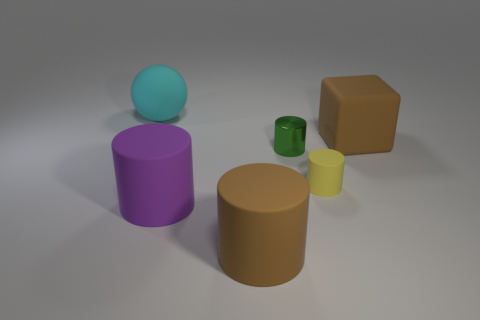What number of objects are either tiny red objects or brown rubber objects?
Ensure brevity in your answer.  2. What size is the brown rubber thing that is the same shape as the green object?
Your response must be concise. Large. The cyan matte object has what size?
Provide a short and direct response. Large. Are there more yellow rubber objects that are in front of the large matte ball than small red blocks?
Provide a short and direct response. Yes. Is there any other thing that is made of the same material as the tiny green object?
Make the answer very short. No. There is a large matte object to the right of the green metal cylinder; is it the same color as the matte cylinder in front of the large purple cylinder?
Your response must be concise. Yes. What is the material of the object that is on the right side of the tiny cylinder in front of the cylinder behind the tiny yellow cylinder?
Provide a short and direct response. Rubber. Is the number of big things greater than the number of things?
Provide a short and direct response. No. Is there anything else that has the same color as the big rubber block?
Your answer should be very brief. Yes. The brown block that is made of the same material as the big purple object is what size?
Your response must be concise. Large. 